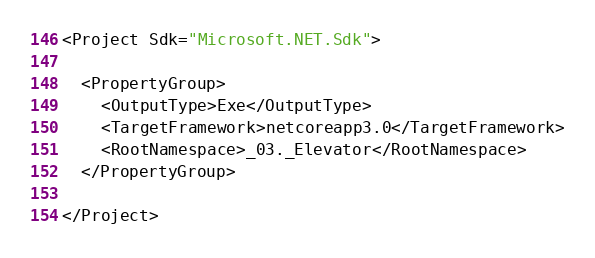<code> <loc_0><loc_0><loc_500><loc_500><_XML_><Project Sdk="Microsoft.NET.Sdk">

  <PropertyGroup>
    <OutputType>Exe</OutputType>
    <TargetFramework>netcoreapp3.0</TargetFramework>
    <RootNamespace>_03._Elevator</RootNamespace>
  </PropertyGroup>

</Project>
</code> 